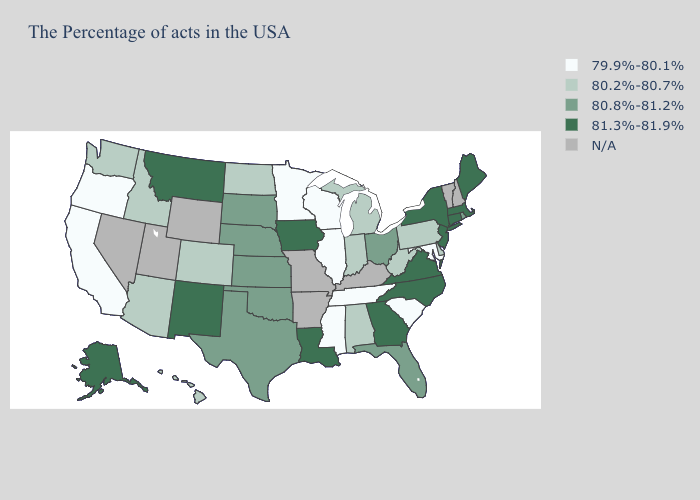What is the value of Nebraska?
Quick response, please. 80.8%-81.2%. Does the first symbol in the legend represent the smallest category?
Keep it brief. Yes. Name the states that have a value in the range 81.3%-81.9%?
Concise answer only. Maine, Massachusetts, Connecticut, New York, New Jersey, Virginia, North Carolina, Georgia, Louisiana, Iowa, New Mexico, Montana, Alaska. Name the states that have a value in the range N/A?
Concise answer only. New Hampshire, Vermont, Kentucky, Missouri, Arkansas, Wyoming, Utah, Nevada. What is the value of Louisiana?
Keep it brief. 81.3%-81.9%. Does the map have missing data?
Answer briefly. Yes. Does Nebraska have the highest value in the USA?
Write a very short answer. No. What is the lowest value in the Northeast?
Keep it brief. 80.2%-80.7%. Does Illinois have the lowest value in the USA?
Quick response, please. Yes. How many symbols are there in the legend?
Quick response, please. 5. Name the states that have a value in the range N/A?
Be succinct. New Hampshire, Vermont, Kentucky, Missouri, Arkansas, Wyoming, Utah, Nevada. What is the highest value in states that border Massachusetts?
Give a very brief answer. 81.3%-81.9%. Among the states that border Kansas , does Colorado have the lowest value?
Be succinct. Yes. Among the states that border Kansas , does Oklahoma have the lowest value?
Short answer required. No. 